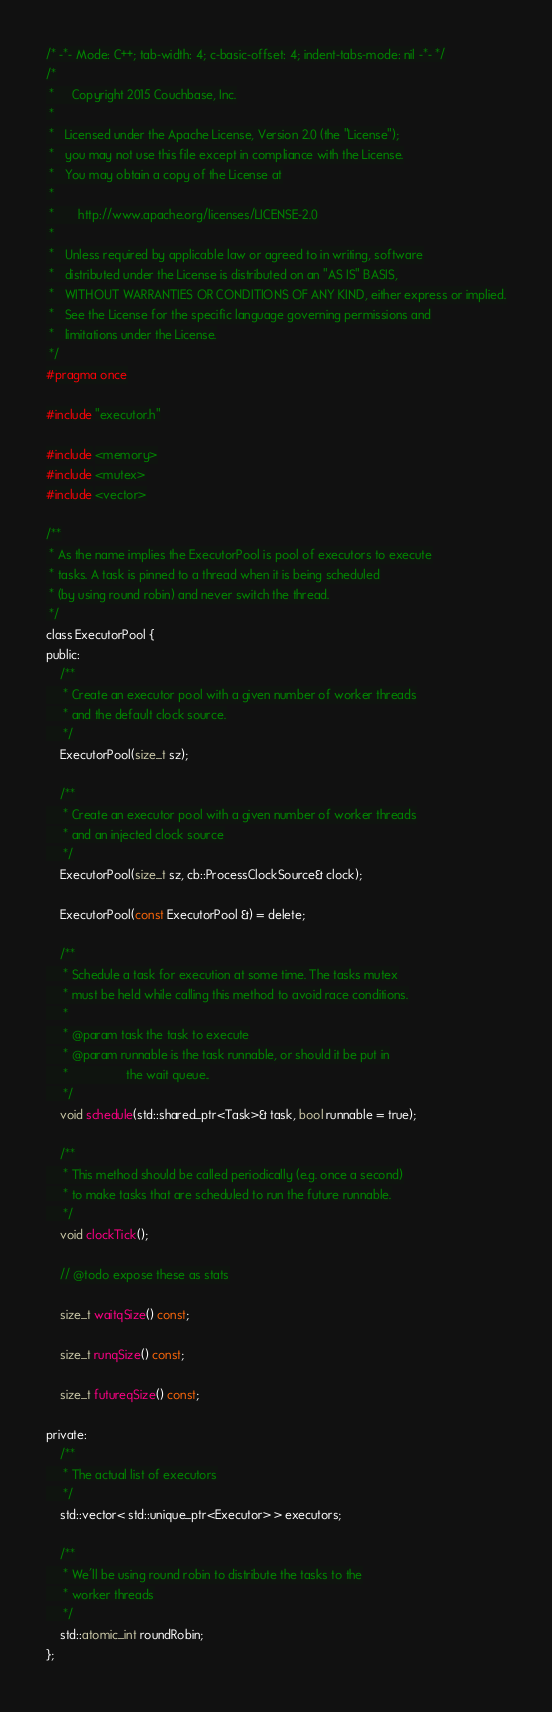Convert code to text. <code><loc_0><loc_0><loc_500><loc_500><_C_>/* -*- Mode: C++; tab-width: 4; c-basic-offset: 4; indent-tabs-mode: nil -*- */
/*
 *     Copyright 2015 Couchbase, Inc.
 *
 *   Licensed under the Apache License, Version 2.0 (the "License");
 *   you may not use this file except in compliance with the License.
 *   You may obtain a copy of the License at
 *
 *       http://www.apache.org/licenses/LICENSE-2.0
 *
 *   Unless required by applicable law or agreed to in writing, software
 *   distributed under the License is distributed on an "AS IS" BASIS,
 *   WITHOUT WARRANTIES OR CONDITIONS OF ANY KIND, either express or implied.
 *   See the License for the specific language governing permissions and
 *   limitations under the License.
 */
#pragma once

#include "executor.h"

#include <memory>
#include <mutex>
#include <vector>

/**
 * As the name implies the ExecutorPool is pool of executors to execute
 * tasks. A task is pinned to a thread when it is being scheduled
 * (by using round robin) and never switch the thread.
 */
class ExecutorPool {
public:
    /**
     * Create an executor pool with a given number of worker threads
     * and the default clock source.
     */
    ExecutorPool(size_t sz);

    /**
     * Create an executor pool with a given number of worker threads
     * and an injected clock source
     */
    ExecutorPool(size_t sz, cb::ProcessClockSource& clock);

    ExecutorPool(const ExecutorPool &) = delete;

    /**
     * Schedule a task for execution at some time. The tasks mutex
     * must be held while calling this method to avoid race conditions.
     *
     * @param task the task to execute
     * @param runnable is the task runnable, or should it be put in
     *                 the wait queue..
     */
    void schedule(std::shared_ptr<Task>& task, bool runnable = true);

    /**
     * This method should be called periodically (e.g. once a second)
     * to make tasks that are scheduled to run the future runnable.
     */
    void clockTick();

    // @todo expose these as stats

    size_t waitqSize() const;

    size_t runqSize() const;

    size_t futureqSize() const;

private:
    /**
     * The actual list of executors
     */
    std::vector< std::unique_ptr<Executor> > executors;

    /**
     * We'll be using round robin to distribute the tasks to the
     * worker threads
     */
    std::atomic_int roundRobin;
};
</code> 